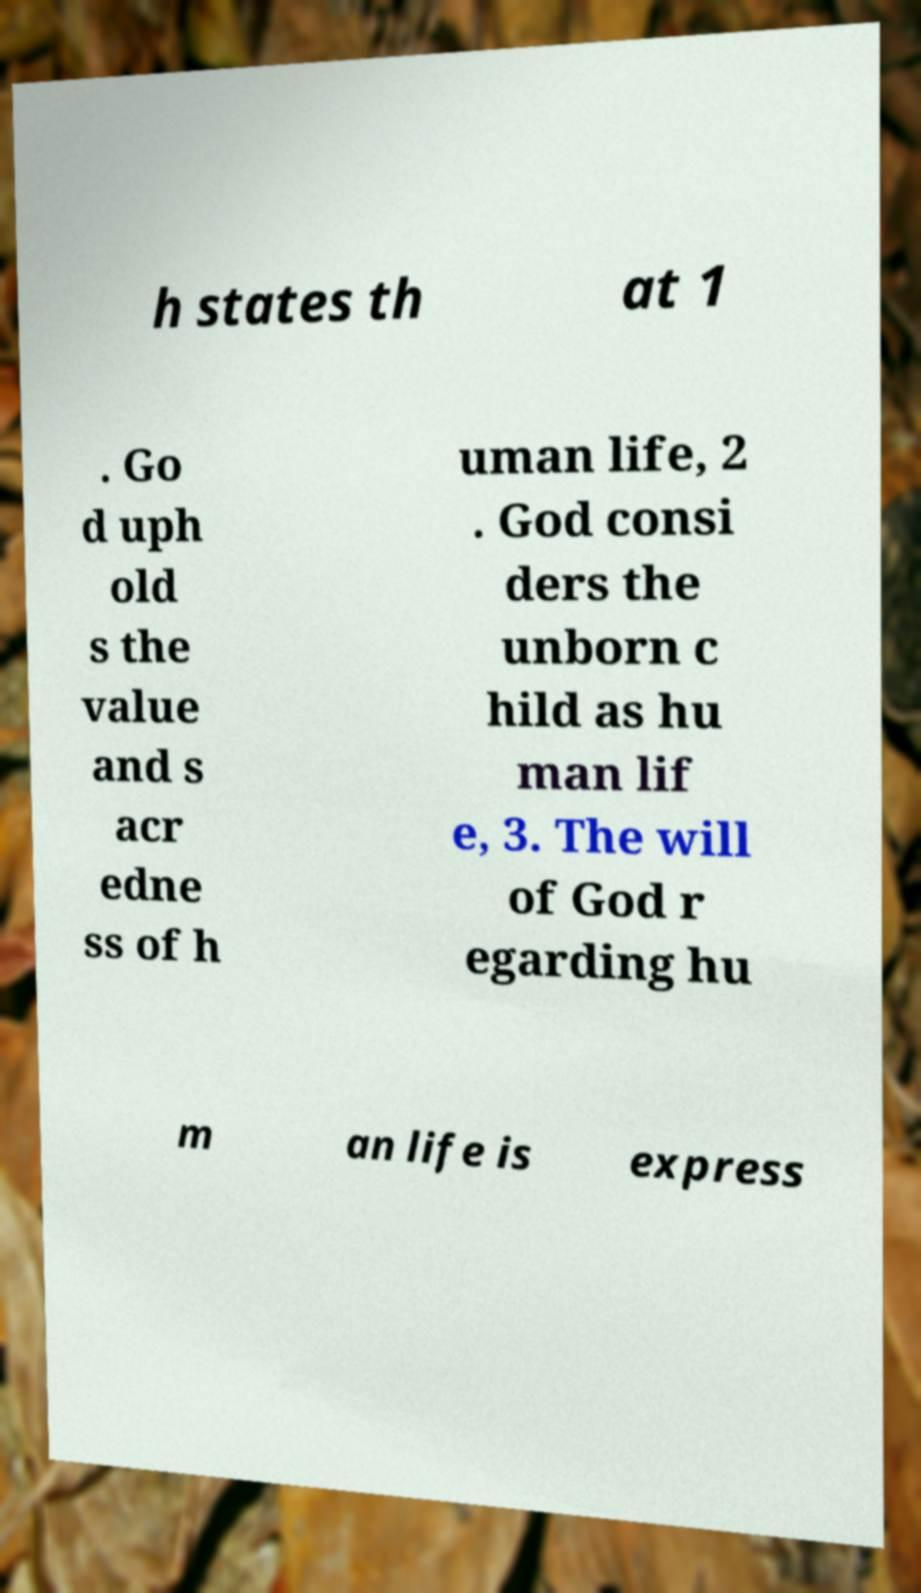I need the written content from this picture converted into text. Can you do that? h states th at 1 . Go d uph old s the value and s acr edne ss of h uman life, 2 . God consi ders the unborn c hild as hu man lif e, 3. The will of God r egarding hu m an life is express 